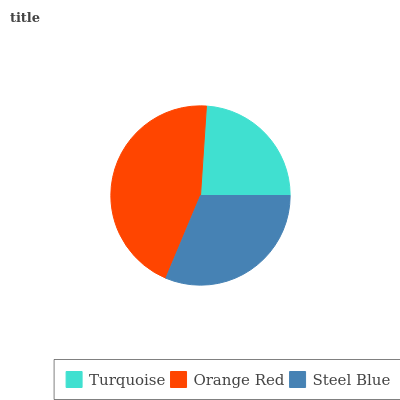Is Turquoise the minimum?
Answer yes or no. Yes. Is Orange Red the maximum?
Answer yes or no. Yes. Is Steel Blue the minimum?
Answer yes or no. No. Is Steel Blue the maximum?
Answer yes or no. No. Is Orange Red greater than Steel Blue?
Answer yes or no. Yes. Is Steel Blue less than Orange Red?
Answer yes or no. Yes. Is Steel Blue greater than Orange Red?
Answer yes or no. No. Is Orange Red less than Steel Blue?
Answer yes or no. No. Is Steel Blue the high median?
Answer yes or no. Yes. Is Steel Blue the low median?
Answer yes or no. Yes. Is Turquoise the high median?
Answer yes or no. No. Is Orange Red the low median?
Answer yes or no. No. 